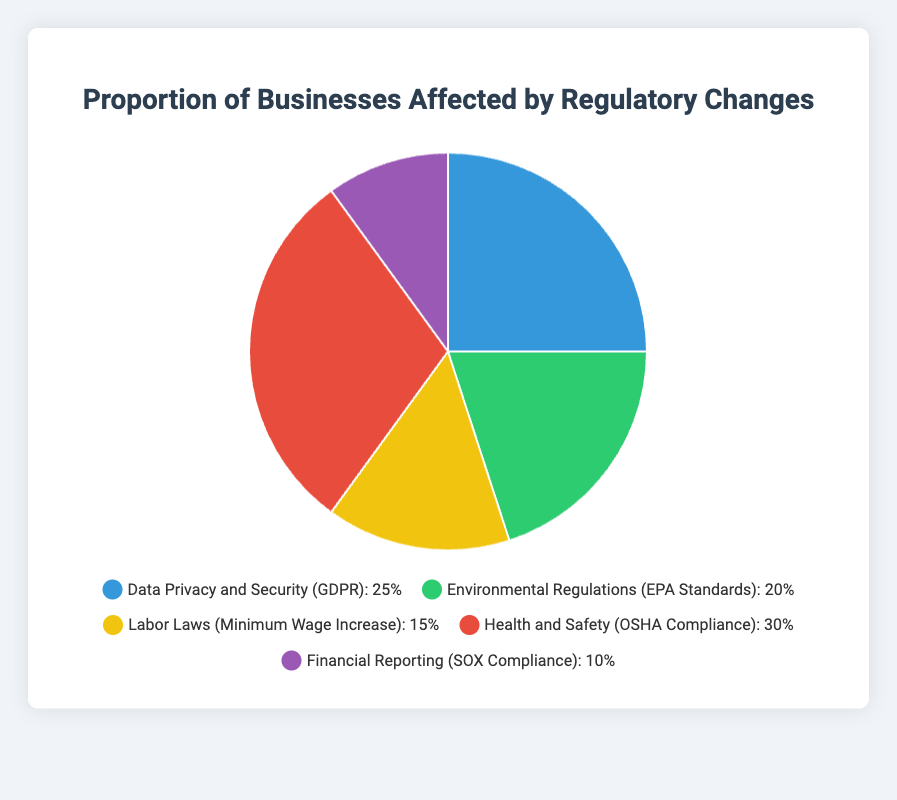What is the total percentage of businesses affected by all the regulatory changes combined? To find the total percentage, add up the percentages for all the regulatory changes: 25% (GDPR) + 20% (EPA Standards) + 15% (Minimum Wage Increase) + 30% (OSHA Compliance) + 10% (SOX Compliance). The total is 25 + 20 + 15 + 30 + 10 = 100%.
Answer: 100% Which regulatory change affects the highest proportion of businesses? Look at the segment with the largest percentage. The "Health and Safety (OSHA Compliance)" segment affects 30% of businesses, which is the highest proportion.
Answer: Health and Safety (OSHA Compliance) Which regulatory change has the smallest impact on businesses? Identify the segment with the smallest percentage value. "Financial Reporting (SOX Compliance)" affects only 10% of businesses, which is the smallest impact.
Answer: Financial Reporting (SOX Compliance) How many more businesses are affected by Health and Safety regulations compared to Labor Laws? Subtract the percentage affected by Labor Laws (15%) from the percentage affected by Health and Safety (30%): 30% - 15% = 15%.
Answer: 15% What is the average percentage of businesses affected by Data Privacy and Security, Environmental Regulations, and Financial Reporting regulations? Add the percentages for these three regulations: 25% (GDPR) + 20% (EPA Standards) + 10% (SOX Compliance) = 55%. Then divide by the number of regulations: 55% / 3 = 18.33%.
Answer: 18.33% Are more businesses affected by Environmental Regulations than by Labor Laws? Compare the percentage values: Environmental Regulations affect 20% of businesses, while Labor Laws affect 15%. Since 20% > 15%, more businesses are affected by Environmental Regulations.
Answer: Yes If a business is affected by any one of these regulatory changes, what is the probability that it is affected by GDPR? GDPR affects 25% of businesses out of the total 100% affected by any regulation. Thus, the probability is 25 out of 100, or 25%.
Answer: 25% What is the sum of the percentages of businesses affected by both GDPR and OSHA Compliance? Add the percentages for GDPR (25%) and OSHA Compliance (30%): 25% + 30% = 55%.
Answer: 55% What is the ratio of businesses affected by OSHA Compliance to those affected by SOX Compliance? The percentage affected by OSHA Compliance is 30%, and by SOX Compliance is 10%. The ratio is 30% / 10% = 3:1.
Answer: 3:1 Comparing GDPR and EPA Standards, by how much is the percentage of businesses affected by GDPR greater? Subtract the percentage of businesses affected by EPA Standards (20%) from those affected by GDPR (25%): 25% - 20% = 5%.
Answer: 5% 